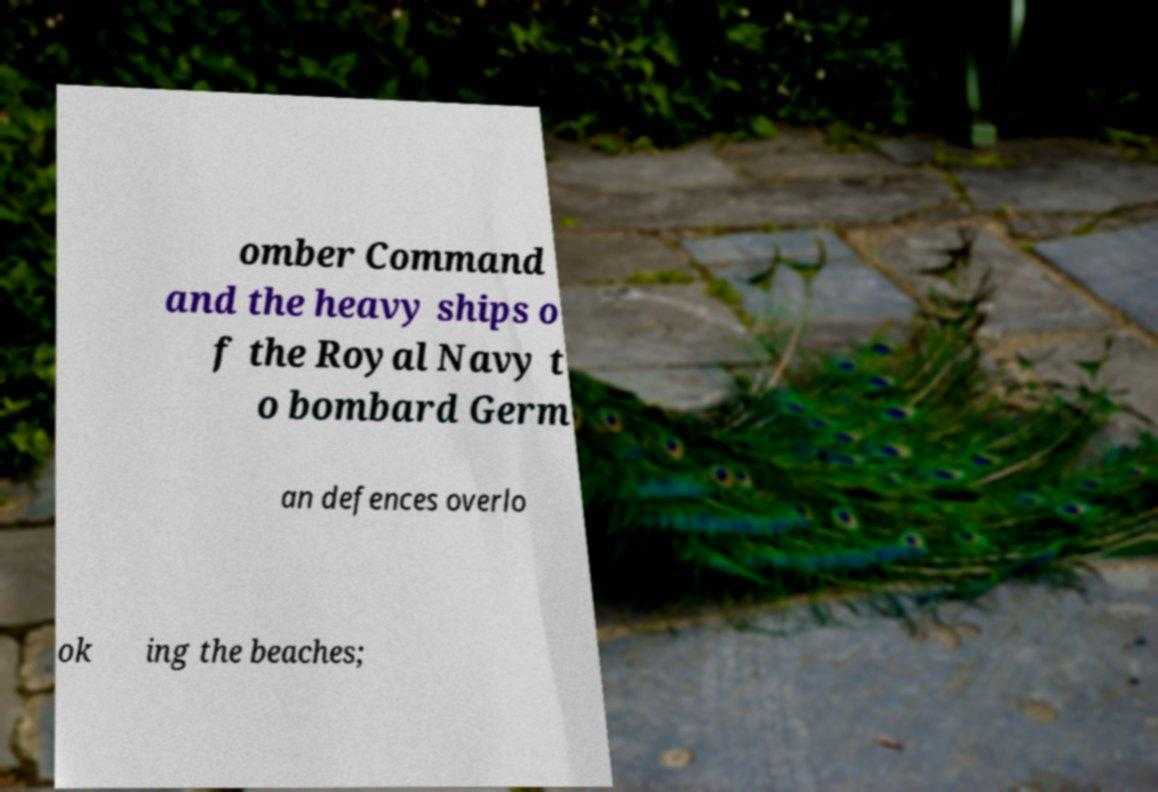Please identify and transcribe the text found in this image. omber Command and the heavy ships o f the Royal Navy t o bombard Germ an defences overlo ok ing the beaches; 